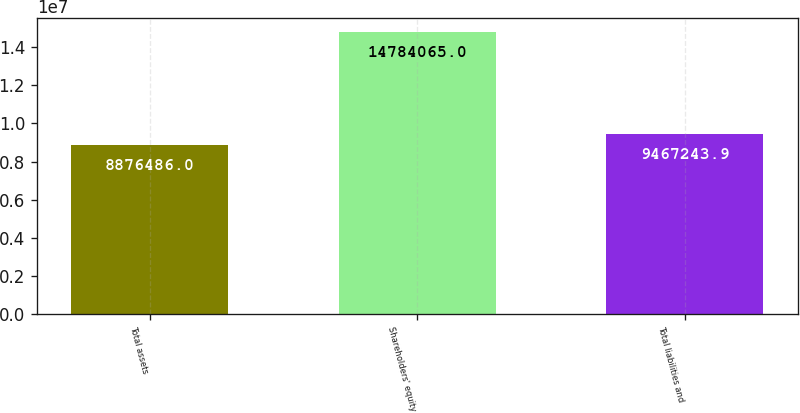<chart> <loc_0><loc_0><loc_500><loc_500><bar_chart><fcel>Total assets<fcel>Shareholders' equity<fcel>Total liabilities and<nl><fcel>8.87649e+06<fcel>1.47841e+07<fcel>9.46724e+06<nl></chart> 